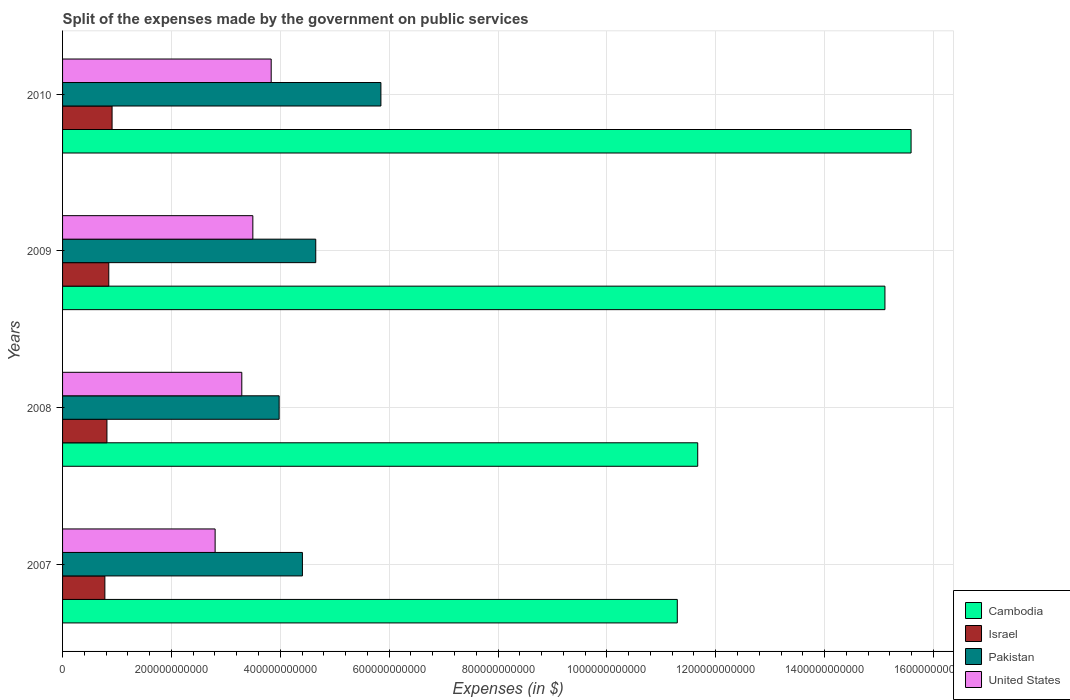How many groups of bars are there?
Keep it short and to the point. 4. Are the number of bars per tick equal to the number of legend labels?
Keep it short and to the point. Yes. How many bars are there on the 1st tick from the top?
Give a very brief answer. 4. How many bars are there on the 1st tick from the bottom?
Offer a terse response. 4. In how many cases, is the number of bars for a given year not equal to the number of legend labels?
Your answer should be compact. 0. What is the expenses made by the government on public services in Pakistan in 2010?
Make the answer very short. 5.85e+11. Across all years, what is the maximum expenses made by the government on public services in United States?
Ensure brevity in your answer.  3.83e+11. Across all years, what is the minimum expenses made by the government on public services in Pakistan?
Your response must be concise. 3.98e+11. In which year was the expenses made by the government on public services in Israel minimum?
Make the answer very short. 2007. What is the total expenses made by the government on public services in United States in the graph?
Your response must be concise. 1.34e+12. What is the difference between the expenses made by the government on public services in Israel in 2008 and that in 2009?
Ensure brevity in your answer.  -3.39e+09. What is the difference between the expenses made by the government on public services in Cambodia in 2010 and the expenses made by the government on public services in Israel in 2007?
Give a very brief answer. 1.48e+12. What is the average expenses made by the government on public services in Israel per year?
Offer a very short reply. 8.38e+1. In the year 2007, what is the difference between the expenses made by the government on public services in Israel and expenses made by the government on public services in United States?
Ensure brevity in your answer.  -2.03e+11. In how many years, is the expenses made by the government on public services in Pakistan greater than 760000000000 $?
Your answer should be compact. 0. What is the ratio of the expenses made by the government on public services in Israel in 2007 to that in 2008?
Your answer should be compact. 0.95. Is the difference between the expenses made by the government on public services in Israel in 2008 and 2010 greater than the difference between the expenses made by the government on public services in United States in 2008 and 2010?
Your answer should be very brief. Yes. What is the difference between the highest and the second highest expenses made by the government on public services in United States?
Provide a succinct answer. 3.37e+1. What is the difference between the highest and the lowest expenses made by the government on public services in United States?
Provide a short and direct response. 1.03e+11. What does the 1st bar from the top in 2008 represents?
Keep it short and to the point. United States. What does the 4th bar from the bottom in 2010 represents?
Offer a terse response. United States. Are all the bars in the graph horizontal?
Your answer should be compact. Yes. How many years are there in the graph?
Give a very brief answer. 4. What is the difference between two consecutive major ticks on the X-axis?
Provide a short and direct response. 2.00e+11. Does the graph contain any zero values?
Your answer should be compact. No. Where does the legend appear in the graph?
Keep it short and to the point. Bottom right. How many legend labels are there?
Provide a short and direct response. 4. What is the title of the graph?
Give a very brief answer. Split of the expenses made by the government on public services. What is the label or title of the X-axis?
Give a very brief answer. Expenses (in $). What is the Expenses (in $) of Cambodia in 2007?
Your answer should be very brief. 1.13e+12. What is the Expenses (in $) in Israel in 2007?
Give a very brief answer. 7.77e+1. What is the Expenses (in $) in Pakistan in 2007?
Make the answer very short. 4.41e+11. What is the Expenses (in $) in United States in 2007?
Provide a short and direct response. 2.80e+11. What is the Expenses (in $) of Cambodia in 2008?
Give a very brief answer. 1.17e+12. What is the Expenses (in $) in Israel in 2008?
Provide a succinct answer. 8.15e+1. What is the Expenses (in $) of Pakistan in 2008?
Ensure brevity in your answer.  3.98e+11. What is the Expenses (in $) in United States in 2008?
Your answer should be very brief. 3.29e+11. What is the Expenses (in $) in Cambodia in 2009?
Give a very brief answer. 1.51e+12. What is the Expenses (in $) of Israel in 2009?
Keep it short and to the point. 8.49e+1. What is the Expenses (in $) in Pakistan in 2009?
Offer a terse response. 4.65e+11. What is the Expenses (in $) in United States in 2009?
Your answer should be compact. 3.50e+11. What is the Expenses (in $) in Cambodia in 2010?
Make the answer very short. 1.56e+12. What is the Expenses (in $) in Israel in 2010?
Keep it short and to the point. 9.10e+1. What is the Expenses (in $) of Pakistan in 2010?
Give a very brief answer. 5.85e+11. What is the Expenses (in $) of United States in 2010?
Offer a terse response. 3.83e+11. Across all years, what is the maximum Expenses (in $) in Cambodia?
Offer a terse response. 1.56e+12. Across all years, what is the maximum Expenses (in $) in Israel?
Provide a short and direct response. 9.10e+1. Across all years, what is the maximum Expenses (in $) of Pakistan?
Provide a succinct answer. 5.85e+11. Across all years, what is the maximum Expenses (in $) in United States?
Your response must be concise. 3.83e+11. Across all years, what is the minimum Expenses (in $) of Cambodia?
Provide a short and direct response. 1.13e+12. Across all years, what is the minimum Expenses (in $) of Israel?
Make the answer very short. 7.77e+1. Across all years, what is the minimum Expenses (in $) of Pakistan?
Your answer should be very brief. 3.98e+11. Across all years, what is the minimum Expenses (in $) in United States?
Provide a short and direct response. 2.80e+11. What is the total Expenses (in $) of Cambodia in the graph?
Offer a very short reply. 5.37e+12. What is the total Expenses (in $) of Israel in the graph?
Provide a succinct answer. 3.35e+11. What is the total Expenses (in $) of Pakistan in the graph?
Your answer should be compact. 1.89e+12. What is the total Expenses (in $) of United States in the graph?
Provide a succinct answer. 1.34e+12. What is the difference between the Expenses (in $) of Cambodia in 2007 and that in 2008?
Your answer should be very brief. -3.75e+1. What is the difference between the Expenses (in $) in Israel in 2007 and that in 2008?
Provide a succinct answer. -3.79e+09. What is the difference between the Expenses (in $) of Pakistan in 2007 and that in 2008?
Your response must be concise. 4.28e+1. What is the difference between the Expenses (in $) in United States in 2007 and that in 2008?
Provide a succinct answer. -4.90e+1. What is the difference between the Expenses (in $) of Cambodia in 2007 and that in 2009?
Ensure brevity in your answer.  -3.81e+11. What is the difference between the Expenses (in $) of Israel in 2007 and that in 2009?
Give a very brief answer. -7.18e+09. What is the difference between the Expenses (in $) in Pakistan in 2007 and that in 2009?
Ensure brevity in your answer.  -2.45e+1. What is the difference between the Expenses (in $) in United States in 2007 and that in 2009?
Give a very brief answer. -6.93e+1. What is the difference between the Expenses (in $) in Cambodia in 2007 and that in 2010?
Make the answer very short. -4.30e+11. What is the difference between the Expenses (in $) in Israel in 2007 and that in 2010?
Make the answer very short. -1.32e+1. What is the difference between the Expenses (in $) of Pakistan in 2007 and that in 2010?
Provide a succinct answer. -1.44e+11. What is the difference between the Expenses (in $) in United States in 2007 and that in 2010?
Give a very brief answer. -1.03e+11. What is the difference between the Expenses (in $) of Cambodia in 2008 and that in 2009?
Ensure brevity in your answer.  -3.44e+11. What is the difference between the Expenses (in $) of Israel in 2008 and that in 2009?
Keep it short and to the point. -3.39e+09. What is the difference between the Expenses (in $) in Pakistan in 2008 and that in 2009?
Give a very brief answer. -6.72e+1. What is the difference between the Expenses (in $) in United States in 2008 and that in 2009?
Your answer should be compact. -2.03e+1. What is the difference between the Expenses (in $) of Cambodia in 2008 and that in 2010?
Offer a very short reply. -3.92e+11. What is the difference between the Expenses (in $) of Israel in 2008 and that in 2010?
Keep it short and to the point. -9.45e+09. What is the difference between the Expenses (in $) of Pakistan in 2008 and that in 2010?
Make the answer very short. -1.87e+11. What is the difference between the Expenses (in $) in United States in 2008 and that in 2010?
Provide a succinct answer. -5.40e+1. What is the difference between the Expenses (in $) in Cambodia in 2009 and that in 2010?
Offer a terse response. -4.80e+1. What is the difference between the Expenses (in $) in Israel in 2009 and that in 2010?
Give a very brief answer. -6.05e+09. What is the difference between the Expenses (in $) of Pakistan in 2009 and that in 2010?
Your answer should be very brief. -1.20e+11. What is the difference between the Expenses (in $) in United States in 2009 and that in 2010?
Provide a short and direct response. -3.37e+1. What is the difference between the Expenses (in $) of Cambodia in 2007 and the Expenses (in $) of Israel in 2008?
Provide a short and direct response. 1.05e+12. What is the difference between the Expenses (in $) in Cambodia in 2007 and the Expenses (in $) in Pakistan in 2008?
Your response must be concise. 7.32e+11. What is the difference between the Expenses (in $) in Cambodia in 2007 and the Expenses (in $) in United States in 2008?
Make the answer very short. 8.00e+11. What is the difference between the Expenses (in $) of Israel in 2007 and the Expenses (in $) of Pakistan in 2008?
Provide a succinct answer. -3.20e+11. What is the difference between the Expenses (in $) in Israel in 2007 and the Expenses (in $) in United States in 2008?
Ensure brevity in your answer.  -2.52e+11. What is the difference between the Expenses (in $) in Pakistan in 2007 and the Expenses (in $) in United States in 2008?
Offer a very short reply. 1.11e+11. What is the difference between the Expenses (in $) of Cambodia in 2007 and the Expenses (in $) of Israel in 2009?
Ensure brevity in your answer.  1.04e+12. What is the difference between the Expenses (in $) in Cambodia in 2007 and the Expenses (in $) in Pakistan in 2009?
Give a very brief answer. 6.64e+11. What is the difference between the Expenses (in $) of Cambodia in 2007 and the Expenses (in $) of United States in 2009?
Your response must be concise. 7.80e+11. What is the difference between the Expenses (in $) in Israel in 2007 and the Expenses (in $) in Pakistan in 2009?
Make the answer very short. -3.87e+11. What is the difference between the Expenses (in $) of Israel in 2007 and the Expenses (in $) of United States in 2009?
Offer a very short reply. -2.72e+11. What is the difference between the Expenses (in $) of Pakistan in 2007 and the Expenses (in $) of United States in 2009?
Keep it short and to the point. 9.11e+1. What is the difference between the Expenses (in $) of Cambodia in 2007 and the Expenses (in $) of Israel in 2010?
Make the answer very short. 1.04e+12. What is the difference between the Expenses (in $) in Cambodia in 2007 and the Expenses (in $) in Pakistan in 2010?
Your response must be concise. 5.45e+11. What is the difference between the Expenses (in $) of Cambodia in 2007 and the Expenses (in $) of United States in 2010?
Keep it short and to the point. 7.46e+11. What is the difference between the Expenses (in $) in Israel in 2007 and the Expenses (in $) in Pakistan in 2010?
Offer a terse response. -5.07e+11. What is the difference between the Expenses (in $) in Israel in 2007 and the Expenses (in $) in United States in 2010?
Provide a succinct answer. -3.06e+11. What is the difference between the Expenses (in $) of Pakistan in 2007 and the Expenses (in $) of United States in 2010?
Give a very brief answer. 5.74e+1. What is the difference between the Expenses (in $) in Cambodia in 2008 and the Expenses (in $) in Israel in 2009?
Provide a short and direct response. 1.08e+12. What is the difference between the Expenses (in $) in Cambodia in 2008 and the Expenses (in $) in Pakistan in 2009?
Ensure brevity in your answer.  7.02e+11. What is the difference between the Expenses (in $) in Cambodia in 2008 and the Expenses (in $) in United States in 2009?
Ensure brevity in your answer.  8.17e+11. What is the difference between the Expenses (in $) in Israel in 2008 and the Expenses (in $) in Pakistan in 2009?
Keep it short and to the point. -3.84e+11. What is the difference between the Expenses (in $) of Israel in 2008 and the Expenses (in $) of United States in 2009?
Offer a very short reply. -2.68e+11. What is the difference between the Expenses (in $) of Pakistan in 2008 and the Expenses (in $) of United States in 2009?
Keep it short and to the point. 4.83e+1. What is the difference between the Expenses (in $) of Cambodia in 2008 and the Expenses (in $) of Israel in 2010?
Offer a terse response. 1.08e+12. What is the difference between the Expenses (in $) in Cambodia in 2008 and the Expenses (in $) in Pakistan in 2010?
Provide a succinct answer. 5.82e+11. What is the difference between the Expenses (in $) of Cambodia in 2008 and the Expenses (in $) of United States in 2010?
Keep it short and to the point. 7.84e+11. What is the difference between the Expenses (in $) of Israel in 2008 and the Expenses (in $) of Pakistan in 2010?
Provide a succinct answer. -5.03e+11. What is the difference between the Expenses (in $) in Israel in 2008 and the Expenses (in $) in United States in 2010?
Make the answer very short. -3.02e+11. What is the difference between the Expenses (in $) in Pakistan in 2008 and the Expenses (in $) in United States in 2010?
Provide a short and direct response. 1.46e+1. What is the difference between the Expenses (in $) in Cambodia in 2009 and the Expenses (in $) in Israel in 2010?
Your answer should be very brief. 1.42e+12. What is the difference between the Expenses (in $) of Cambodia in 2009 and the Expenses (in $) of Pakistan in 2010?
Give a very brief answer. 9.26e+11. What is the difference between the Expenses (in $) of Cambodia in 2009 and the Expenses (in $) of United States in 2010?
Provide a succinct answer. 1.13e+12. What is the difference between the Expenses (in $) in Israel in 2009 and the Expenses (in $) in Pakistan in 2010?
Offer a terse response. -5.00e+11. What is the difference between the Expenses (in $) of Israel in 2009 and the Expenses (in $) of United States in 2010?
Ensure brevity in your answer.  -2.98e+11. What is the difference between the Expenses (in $) of Pakistan in 2009 and the Expenses (in $) of United States in 2010?
Ensure brevity in your answer.  8.19e+1. What is the average Expenses (in $) of Cambodia per year?
Give a very brief answer. 1.34e+12. What is the average Expenses (in $) of Israel per year?
Offer a terse response. 8.38e+1. What is the average Expenses (in $) of Pakistan per year?
Make the answer very short. 4.72e+11. What is the average Expenses (in $) in United States per year?
Make the answer very short. 3.36e+11. In the year 2007, what is the difference between the Expenses (in $) of Cambodia and Expenses (in $) of Israel?
Provide a succinct answer. 1.05e+12. In the year 2007, what is the difference between the Expenses (in $) in Cambodia and Expenses (in $) in Pakistan?
Ensure brevity in your answer.  6.89e+11. In the year 2007, what is the difference between the Expenses (in $) in Cambodia and Expenses (in $) in United States?
Your answer should be very brief. 8.49e+11. In the year 2007, what is the difference between the Expenses (in $) of Israel and Expenses (in $) of Pakistan?
Offer a terse response. -3.63e+11. In the year 2007, what is the difference between the Expenses (in $) of Israel and Expenses (in $) of United States?
Keep it short and to the point. -2.03e+11. In the year 2007, what is the difference between the Expenses (in $) in Pakistan and Expenses (in $) in United States?
Your response must be concise. 1.60e+11. In the year 2008, what is the difference between the Expenses (in $) of Cambodia and Expenses (in $) of Israel?
Offer a very short reply. 1.09e+12. In the year 2008, what is the difference between the Expenses (in $) in Cambodia and Expenses (in $) in Pakistan?
Offer a very short reply. 7.69e+11. In the year 2008, what is the difference between the Expenses (in $) of Cambodia and Expenses (in $) of United States?
Provide a succinct answer. 8.38e+11. In the year 2008, what is the difference between the Expenses (in $) of Israel and Expenses (in $) of Pakistan?
Make the answer very short. -3.16e+11. In the year 2008, what is the difference between the Expenses (in $) of Israel and Expenses (in $) of United States?
Offer a terse response. -2.48e+11. In the year 2008, what is the difference between the Expenses (in $) of Pakistan and Expenses (in $) of United States?
Provide a short and direct response. 6.86e+1. In the year 2009, what is the difference between the Expenses (in $) in Cambodia and Expenses (in $) in Israel?
Ensure brevity in your answer.  1.43e+12. In the year 2009, what is the difference between the Expenses (in $) of Cambodia and Expenses (in $) of Pakistan?
Provide a succinct answer. 1.05e+12. In the year 2009, what is the difference between the Expenses (in $) of Cambodia and Expenses (in $) of United States?
Your answer should be very brief. 1.16e+12. In the year 2009, what is the difference between the Expenses (in $) in Israel and Expenses (in $) in Pakistan?
Your answer should be compact. -3.80e+11. In the year 2009, what is the difference between the Expenses (in $) of Israel and Expenses (in $) of United States?
Provide a succinct answer. -2.65e+11. In the year 2009, what is the difference between the Expenses (in $) of Pakistan and Expenses (in $) of United States?
Keep it short and to the point. 1.16e+11. In the year 2010, what is the difference between the Expenses (in $) in Cambodia and Expenses (in $) in Israel?
Give a very brief answer. 1.47e+12. In the year 2010, what is the difference between the Expenses (in $) in Cambodia and Expenses (in $) in Pakistan?
Your answer should be very brief. 9.74e+11. In the year 2010, what is the difference between the Expenses (in $) in Cambodia and Expenses (in $) in United States?
Offer a very short reply. 1.18e+12. In the year 2010, what is the difference between the Expenses (in $) in Israel and Expenses (in $) in Pakistan?
Your answer should be compact. -4.94e+11. In the year 2010, what is the difference between the Expenses (in $) of Israel and Expenses (in $) of United States?
Make the answer very short. -2.92e+11. In the year 2010, what is the difference between the Expenses (in $) of Pakistan and Expenses (in $) of United States?
Ensure brevity in your answer.  2.02e+11. What is the ratio of the Expenses (in $) of Cambodia in 2007 to that in 2008?
Your answer should be very brief. 0.97. What is the ratio of the Expenses (in $) of Israel in 2007 to that in 2008?
Ensure brevity in your answer.  0.95. What is the ratio of the Expenses (in $) of Pakistan in 2007 to that in 2008?
Your answer should be compact. 1.11. What is the ratio of the Expenses (in $) of United States in 2007 to that in 2008?
Keep it short and to the point. 0.85. What is the ratio of the Expenses (in $) of Cambodia in 2007 to that in 2009?
Offer a terse response. 0.75. What is the ratio of the Expenses (in $) of Israel in 2007 to that in 2009?
Provide a succinct answer. 0.92. What is the ratio of the Expenses (in $) in Pakistan in 2007 to that in 2009?
Offer a terse response. 0.95. What is the ratio of the Expenses (in $) of United States in 2007 to that in 2009?
Provide a short and direct response. 0.8. What is the ratio of the Expenses (in $) of Cambodia in 2007 to that in 2010?
Your answer should be compact. 0.72. What is the ratio of the Expenses (in $) in Israel in 2007 to that in 2010?
Ensure brevity in your answer.  0.85. What is the ratio of the Expenses (in $) of Pakistan in 2007 to that in 2010?
Your answer should be compact. 0.75. What is the ratio of the Expenses (in $) in United States in 2007 to that in 2010?
Keep it short and to the point. 0.73. What is the ratio of the Expenses (in $) of Cambodia in 2008 to that in 2009?
Provide a short and direct response. 0.77. What is the ratio of the Expenses (in $) of Pakistan in 2008 to that in 2009?
Your response must be concise. 0.86. What is the ratio of the Expenses (in $) of United States in 2008 to that in 2009?
Your answer should be very brief. 0.94. What is the ratio of the Expenses (in $) of Cambodia in 2008 to that in 2010?
Give a very brief answer. 0.75. What is the ratio of the Expenses (in $) of Israel in 2008 to that in 2010?
Offer a terse response. 0.9. What is the ratio of the Expenses (in $) of Pakistan in 2008 to that in 2010?
Ensure brevity in your answer.  0.68. What is the ratio of the Expenses (in $) in United States in 2008 to that in 2010?
Provide a short and direct response. 0.86. What is the ratio of the Expenses (in $) in Cambodia in 2009 to that in 2010?
Offer a terse response. 0.97. What is the ratio of the Expenses (in $) in Israel in 2009 to that in 2010?
Ensure brevity in your answer.  0.93. What is the ratio of the Expenses (in $) of Pakistan in 2009 to that in 2010?
Give a very brief answer. 0.8. What is the ratio of the Expenses (in $) of United States in 2009 to that in 2010?
Your answer should be compact. 0.91. What is the difference between the highest and the second highest Expenses (in $) in Cambodia?
Keep it short and to the point. 4.80e+1. What is the difference between the highest and the second highest Expenses (in $) of Israel?
Ensure brevity in your answer.  6.05e+09. What is the difference between the highest and the second highest Expenses (in $) in Pakistan?
Your answer should be very brief. 1.20e+11. What is the difference between the highest and the second highest Expenses (in $) of United States?
Ensure brevity in your answer.  3.37e+1. What is the difference between the highest and the lowest Expenses (in $) in Cambodia?
Keep it short and to the point. 4.30e+11. What is the difference between the highest and the lowest Expenses (in $) in Israel?
Offer a very short reply. 1.32e+1. What is the difference between the highest and the lowest Expenses (in $) in Pakistan?
Give a very brief answer. 1.87e+11. What is the difference between the highest and the lowest Expenses (in $) of United States?
Provide a succinct answer. 1.03e+11. 